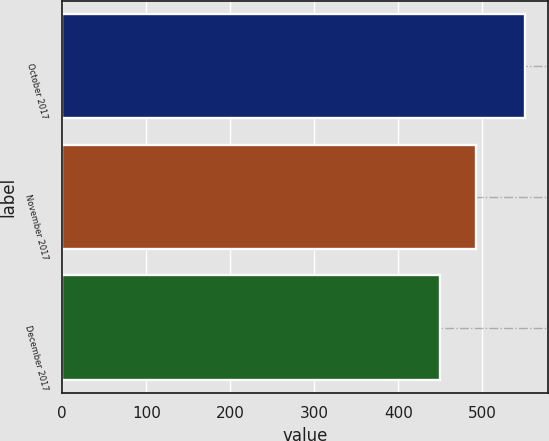<chart> <loc_0><loc_0><loc_500><loc_500><bar_chart><fcel>October 2017<fcel>November 2017<fcel>December 2017<nl><fcel>551<fcel>492<fcel>450<nl></chart> 